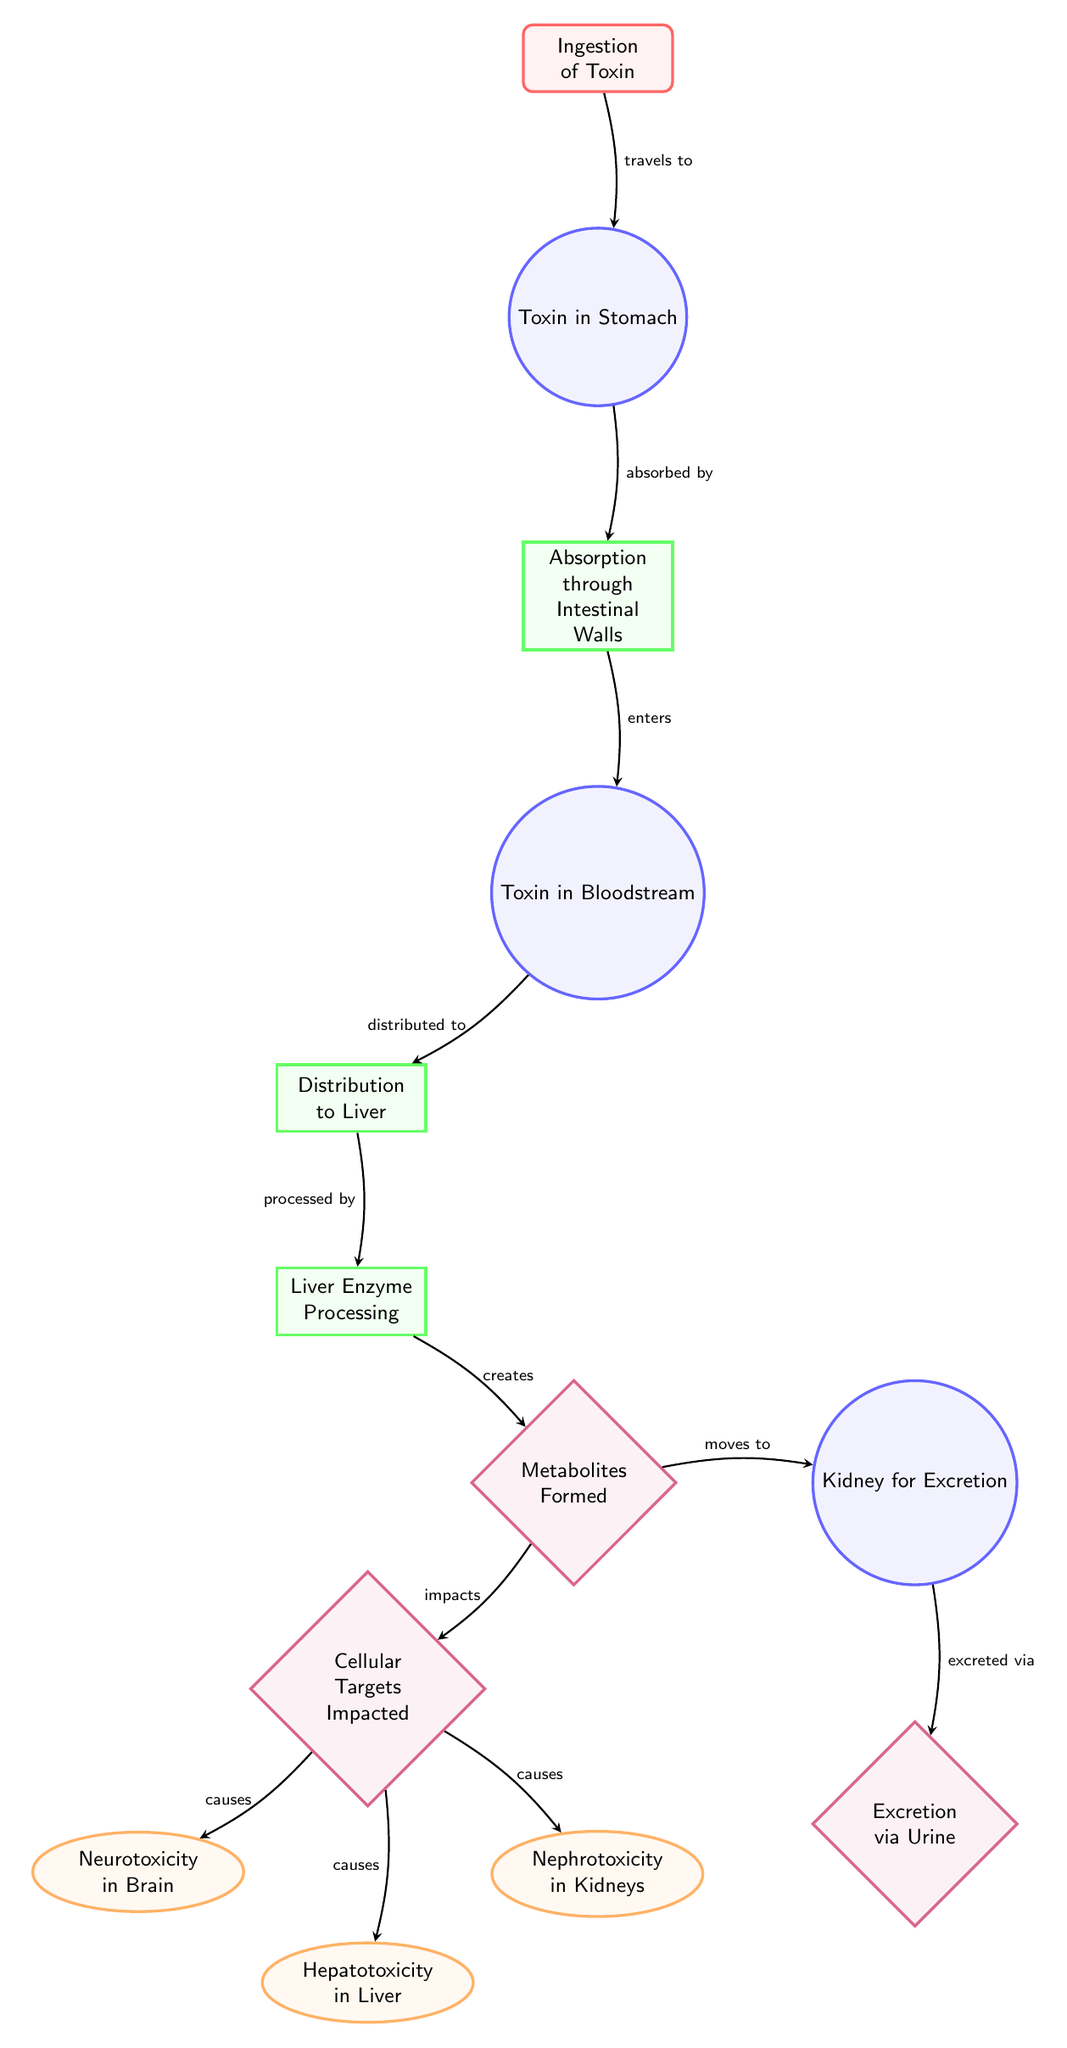What is the first step in the metabolic pathway? The first step in the pathway is the "Ingestion of Toxin", which initiates the process of toxin introduction into the body.
Answer: Ingestion of Toxin How is the toxin processed after being absorbed? After absorption through the intestinal walls, the toxin enters the bloodstream and is then distributed to the liver for processing.
Answer: Liver Enzyme Processing What organ is targeted following the formation of metabolites? The cellular targets affected after metabolite formation include mainly the brain, liver, and kidneys as specified in the diagram.
Answer: Brain, Liver, Kidneys What effect is caused by the toxin in the brain? The diagram indicates that neurotoxicity occurs in the brain as an effect of the toxin.
Answer: Neurotoxicity in Brain How many outcomes are listed in the diagram? There are three outcomes resulting from the impact on cellular targets, specifically: neurotoxicity in the brain, hepatotoxicity in the liver, and nephrotoxicity in the kidneys.
Answer: Three outcomes What happens to the metabolites after the liver processes the toxin? Following liver processing, the metabolites created are transported to the kidneys for excretion via urine.
Answer: Excretion via Urine Which process comes directly after the "Absorption through Intestinal Walls"? The process immediately following absorption is the "Toxin in Bloodstream," indicating the uptake of toxin into the circulatory system.
Answer: Toxin in Bloodstream What cellular impact occurs in the liver due to toxins? The effect in the liver due to toxin presence is hepatotoxicity, which signifies liver damage or dysfunction caused by the toxin.
Answer: Hepatotoxicity in Liver 